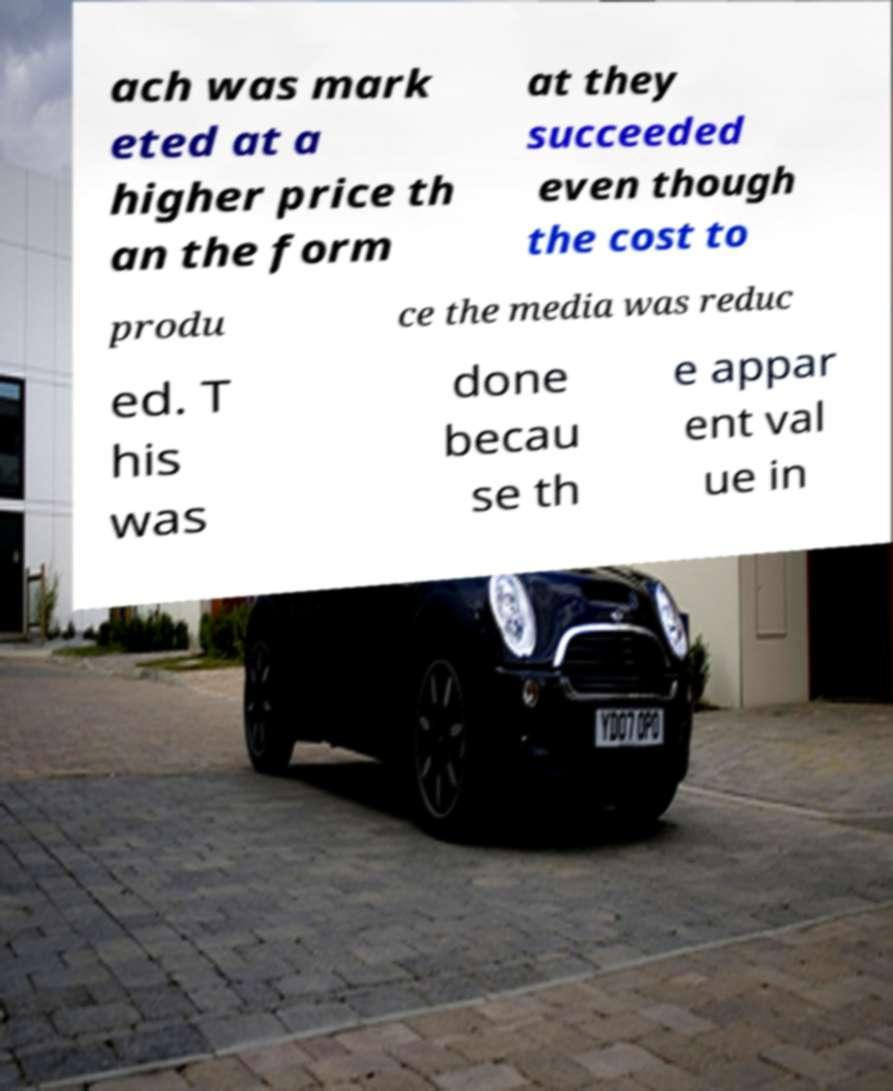I need the written content from this picture converted into text. Can you do that? ach was mark eted at a higher price th an the form at they succeeded even though the cost to produ ce the media was reduc ed. T his was done becau se th e appar ent val ue in 